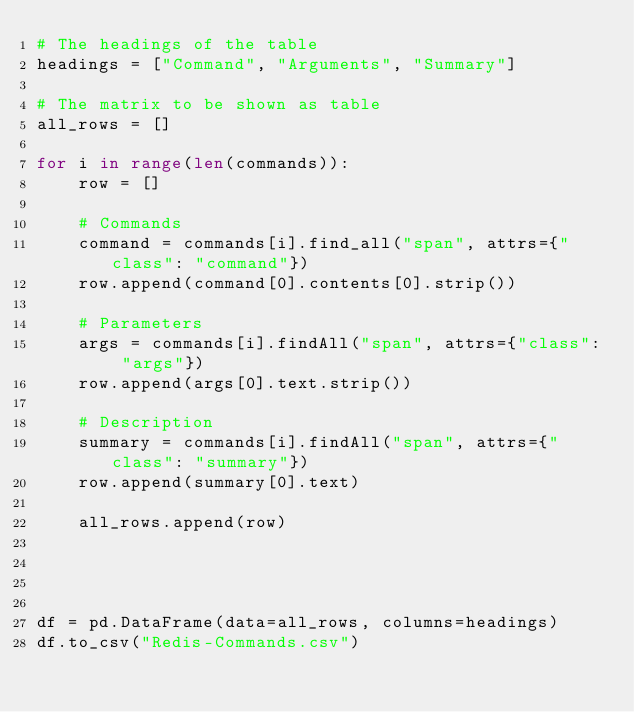Convert code to text. <code><loc_0><loc_0><loc_500><loc_500><_Python_># The headings of the table
headings = ["Command", "Arguments", "Summary"]

# The matrix to be shown as table
all_rows = []

for i in range(len(commands)):
    row = []

    # Commands
    command = commands[i].find_all("span", attrs={"class": "command"})
    row.append(command[0].contents[0].strip())

    # Parameters
    args = commands[i].findAll("span", attrs={"class": "args"})
    row.append(args[0].text.strip())

    # Description
    summary = commands[i].findAll("span", attrs={"class": "summary"})
    row.append(summary[0].text)

    all_rows.append(row)




df = pd.DataFrame(data=all_rows, columns=headings)
df.to_csv("Redis-Commands.csv")
</code> 